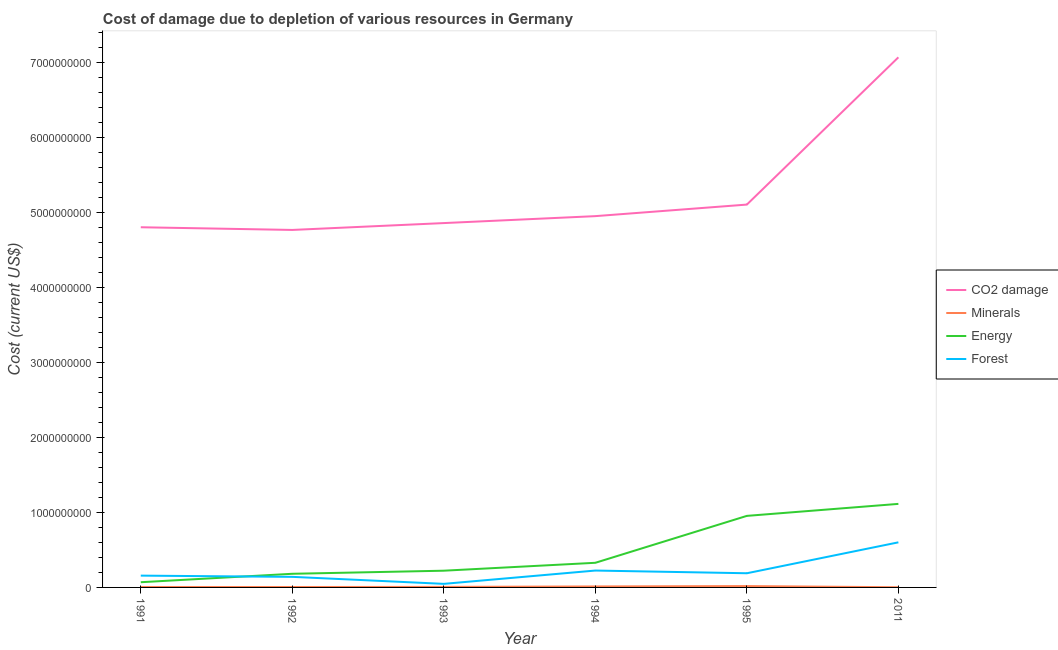Does the line corresponding to cost of damage due to depletion of coal intersect with the line corresponding to cost of damage due to depletion of energy?
Provide a succinct answer. No. What is the cost of damage due to depletion of minerals in 1992?
Your response must be concise. 5.79e+06. Across all years, what is the maximum cost of damage due to depletion of energy?
Offer a terse response. 1.11e+09. Across all years, what is the minimum cost of damage due to depletion of minerals?
Ensure brevity in your answer.  2.65e+06. In which year was the cost of damage due to depletion of minerals minimum?
Make the answer very short. 2011. What is the total cost of damage due to depletion of minerals in the graph?
Offer a very short reply. 5.21e+07. What is the difference between the cost of damage due to depletion of energy in 1995 and that in 2011?
Your response must be concise. -1.60e+08. What is the difference between the cost of damage due to depletion of minerals in 1991 and the cost of damage due to depletion of forests in 1995?
Your response must be concise. -1.83e+08. What is the average cost of damage due to depletion of coal per year?
Keep it short and to the point. 5.26e+09. In the year 1995, what is the difference between the cost of damage due to depletion of minerals and cost of damage due to depletion of energy?
Provide a succinct answer. -9.37e+08. In how many years, is the cost of damage due to depletion of coal greater than 4000000000 US$?
Provide a short and direct response. 6. What is the ratio of the cost of damage due to depletion of coal in 1991 to that in 2011?
Keep it short and to the point. 0.68. Is the difference between the cost of damage due to depletion of energy in 1992 and 1995 greater than the difference between the cost of damage due to depletion of minerals in 1992 and 1995?
Provide a short and direct response. No. What is the difference between the highest and the second highest cost of damage due to depletion of forests?
Keep it short and to the point. 3.76e+08. What is the difference between the highest and the lowest cost of damage due to depletion of coal?
Your answer should be very brief. 2.30e+09. In how many years, is the cost of damage due to depletion of minerals greater than the average cost of damage due to depletion of minerals taken over all years?
Offer a very short reply. 2. Does the cost of damage due to depletion of minerals monotonically increase over the years?
Give a very brief answer. No. Is the cost of damage due to depletion of minerals strictly greater than the cost of damage due to depletion of energy over the years?
Make the answer very short. No. What is the difference between two consecutive major ticks on the Y-axis?
Your response must be concise. 1.00e+09. What is the title of the graph?
Keep it short and to the point. Cost of damage due to depletion of various resources in Germany . What is the label or title of the Y-axis?
Provide a short and direct response. Cost (current US$). What is the Cost (current US$) of CO2 damage in 1991?
Offer a very short reply. 4.80e+09. What is the Cost (current US$) of Minerals in 1991?
Ensure brevity in your answer.  5.85e+06. What is the Cost (current US$) of Energy in 1991?
Offer a terse response. 6.95e+07. What is the Cost (current US$) of Forest in 1991?
Your answer should be compact. 1.57e+08. What is the Cost (current US$) in CO2 damage in 1992?
Ensure brevity in your answer.  4.77e+09. What is the Cost (current US$) in Minerals in 1992?
Make the answer very short. 5.79e+06. What is the Cost (current US$) of Energy in 1992?
Keep it short and to the point. 1.82e+08. What is the Cost (current US$) of Forest in 1992?
Your answer should be compact. 1.41e+08. What is the Cost (current US$) of CO2 damage in 1993?
Keep it short and to the point. 4.86e+09. What is the Cost (current US$) of Minerals in 1993?
Your response must be concise. 7.05e+06. What is the Cost (current US$) in Energy in 1993?
Give a very brief answer. 2.23e+08. What is the Cost (current US$) of Forest in 1993?
Offer a terse response. 4.76e+07. What is the Cost (current US$) in CO2 damage in 1994?
Offer a very short reply. 4.95e+09. What is the Cost (current US$) in Minerals in 1994?
Your answer should be very brief. 1.30e+07. What is the Cost (current US$) of Energy in 1994?
Your answer should be very brief. 3.29e+08. What is the Cost (current US$) in Forest in 1994?
Your response must be concise. 2.25e+08. What is the Cost (current US$) of CO2 damage in 1995?
Give a very brief answer. 5.11e+09. What is the Cost (current US$) in Minerals in 1995?
Offer a terse response. 1.77e+07. What is the Cost (current US$) in Energy in 1995?
Offer a very short reply. 9.54e+08. What is the Cost (current US$) of Forest in 1995?
Provide a short and direct response. 1.89e+08. What is the Cost (current US$) in CO2 damage in 2011?
Offer a very short reply. 7.07e+09. What is the Cost (current US$) in Minerals in 2011?
Offer a very short reply. 2.65e+06. What is the Cost (current US$) in Energy in 2011?
Your answer should be compact. 1.11e+09. What is the Cost (current US$) in Forest in 2011?
Provide a short and direct response. 6.01e+08. Across all years, what is the maximum Cost (current US$) in CO2 damage?
Provide a short and direct response. 7.07e+09. Across all years, what is the maximum Cost (current US$) in Minerals?
Provide a succinct answer. 1.77e+07. Across all years, what is the maximum Cost (current US$) in Energy?
Provide a succinct answer. 1.11e+09. Across all years, what is the maximum Cost (current US$) of Forest?
Offer a terse response. 6.01e+08. Across all years, what is the minimum Cost (current US$) of CO2 damage?
Your response must be concise. 4.77e+09. Across all years, what is the minimum Cost (current US$) in Minerals?
Ensure brevity in your answer.  2.65e+06. Across all years, what is the minimum Cost (current US$) in Energy?
Your answer should be very brief. 6.95e+07. Across all years, what is the minimum Cost (current US$) of Forest?
Give a very brief answer. 4.76e+07. What is the total Cost (current US$) in CO2 damage in the graph?
Keep it short and to the point. 3.16e+1. What is the total Cost (current US$) in Minerals in the graph?
Offer a very short reply. 5.21e+07. What is the total Cost (current US$) in Energy in the graph?
Ensure brevity in your answer.  2.87e+09. What is the total Cost (current US$) of Forest in the graph?
Give a very brief answer. 1.36e+09. What is the difference between the Cost (current US$) in CO2 damage in 1991 and that in 1992?
Your answer should be compact. 3.59e+07. What is the difference between the Cost (current US$) in Minerals in 1991 and that in 1992?
Offer a very short reply. 6.23e+04. What is the difference between the Cost (current US$) of Energy in 1991 and that in 1992?
Offer a terse response. -1.13e+08. What is the difference between the Cost (current US$) in Forest in 1991 and that in 1992?
Offer a terse response. 1.64e+07. What is the difference between the Cost (current US$) in CO2 damage in 1991 and that in 1993?
Your answer should be compact. -5.56e+07. What is the difference between the Cost (current US$) in Minerals in 1991 and that in 1993?
Your answer should be very brief. -1.19e+06. What is the difference between the Cost (current US$) of Energy in 1991 and that in 1993?
Your answer should be compact. -1.54e+08. What is the difference between the Cost (current US$) in Forest in 1991 and that in 1993?
Offer a terse response. 1.10e+08. What is the difference between the Cost (current US$) in CO2 damage in 1991 and that in 1994?
Keep it short and to the point. -1.48e+08. What is the difference between the Cost (current US$) of Minerals in 1991 and that in 1994?
Your answer should be compact. -7.17e+06. What is the difference between the Cost (current US$) of Energy in 1991 and that in 1994?
Ensure brevity in your answer.  -2.59e+08. What is the difference between the Cost (current US$) in Forest in 1991 and that in 1994?
Keep it short and to the point. -6.78e+07. What is the difference between the Cost (current US$) of CO2 damage in 1991 and that in 1995?
Give a very brief answer. -3.02e+08. What is the difference between the Cost (current US$) in Minerals in 1991 and that in 1995?
Provide a short and direct response. -1.19e+07. What is the difference between the Cost (current US$) of Energy in 1991 and that in 1995?
Offer a very short reply. -8.85e+08. What is the difference between the Cost (current US$) in Forest in 1991 and that in 1995?
Provide a succinct answer. -3.16e+07. What is the difference between the Cost (current US$) in CO2 damage in 1991 and that in 2011?
Ensure brevity in your answer.  -2.27e+09. What is the difference between the Cost (current US$) in Minerals in 1991 and that in 2011?
Give a very brief answer. 3.20e+06. What is the difference between the Cost (current US$) in Energy in 1991 and that in 2011?
Give a very brief answer. -1.04e+09. What is the difference between the Cost (current US$) in Forest in 1991 and that in 2011?
Make the answer very short. -4.44e+08. What is the difference between the Cost (current US$) of CO2 damage in 1992 and that in 1993?
Offer a terse response. -9.15e+07. What is the difference between the Cost (current US$) in Minerals in 1992 and that in 1993?
Offer a very short reply. -1.26e+06. What is the difference between the Cost (current US$) in Energy in 1992 and that in 1993?
Provide a short and direct response. -4.12e+07. What is the difference between the Cost (current US$) of Forest in 1992 and that in 1993?
Give a very brief answer. 9.35e+07. What is the difference between the Cost (current US$) in CO2 damage in 1992 and that in 1994?
Offer a very short reply. -1.84e+08. What is the difference between the Cost (current US$) in Minerals in 1992 and that in 1994?
Offer a terse response. -7.23e+06. What is the difference between the Cost (current US$) of Energy in 1992 and that in 1994?
Ensure brevity in your answer.  -1.47e+08. What is the difference between the Cost (current US$) in Forest in 1992 and that in 1994?
Your answer should be very brief. -8.41e+07. What is the difference between the Cost (current US$) of CO2 damage in 1992 and that in 1995?
Offer a terse response. -3.38e+08. What is the difference between the Cost (current US$) in Minerals in 1992 and that in 1995?
Offer a terse response. -1.19e+07. What is the difference between the Cost (current US$) of Energy in 1992 and that in 1995?
Your answer should be very brief. -7.72e+08. What is the difference between the Cost (current US$) of Forest in 1992 and that in 1995?
Provide a short and direct response. -4.80e+07. What is the difference between the Cost (current US$) in CO2 damage in 1992 and that in 2011?
Offer a terse response. -2.30e+09. What is the difference between the Cost (current US$) in Minerals in 1992 and that in 2011?
Provide a succinct answer. 3.14e+06. What is the difference between the Cost (current US$) in Energy in 1992 and that in 2011?
Ensure brevity in your answer.  -9.32e+08. What is the difference between the Cost (current US$) of Forest in 1992 and that in 2011?
Offer a very short reply. -4.60e+08. What is the difference between the Cost (current US$) in CO2 damage in 1993 and that in 1994?
Offer a very short reply. -9.26e+07. What is the difference between the Cost (current US$) of Minerals in 1993 and that in 1994?
Keep it short and to the point. -5.97e+06. What is the difference between the Cost (current US$) of Energy in 1993 and that in 1994?
Give a very brief answer. -1.05e+08. What is the difference between the Cost (current US$) in Forest in 1993 and that in 1994?
Make the answer very short. -1.78e+08. What is the difference between the Cost (current US$) of CO2 damage in 1993 and that in 1995?
Offer a terse response. -2.47e+08. What is the difference between the Cost (current US$) of Minerals in 1993 and that in 1995?
Keep it short and to the point. -1.07e+07. What is the difference between the Cost (current US$) in Energy in 1993 and that in 1995?
Your answer should be compact. -7.31e+08. What is the difference between the Cost (current US$) in Forest in 1993 and that in 1995?
Offer a terse response. -1.41e+08. What is the difference between the Cost (current US$) of CO2 damage in 1993 and that in 2011?
Your response must be concise. -2.21e+09. What is the difference between the Cost (current US$) of Minerals in 1993 and that in 2011?
Ensure brevity in your answer.  4.39e+06. What is the difference between the Cost (current US$) of Energy in 1993 and that in 2011?
Provide a short and direct response. -8.91e+08. What is the difference between the Cost (current US$) of Forest in 1993 and that in 2011?
Your answer should be very brief. -5.54e+08. What is the difference between the Cost (current US$) in CO2 damage in 1994 and that in 1995?
Your answer should be very brief. -1.54e+08. What is the difference between the Cost (current US$) of Minerals in 1994 and that in 1995?
Make the answer very short. -4.72e+06. What is the difference between the Cost (current US$) in Energy in 1994 and that in 1995?
Your answer should be very brief. -6.26e+08. What is the difference between the Cost (current US$) in Forest in 1994 and that in 1995?
Offer a very short reply. 3.62e+07. What is the difference between the Cost (current US$) of CO2 damage in 1994 and that in 2011?
Give a very brief answer. -2.12e+09. What is the difference between the Cost (current US$) in Minerals in 1994 and that in 2011?
Your answer should be compact. 1.04e+07. What is the difference between the Cost (current US$) in Energy in 1994 and that in 2011?
Make the answer very short. -7.86e+08. What is the difference between the Cost (current US$) in Forest in 1994 and that in 2011?
Offer a very short reply. -3.76e+08. What is the difference between the Cost (current US$) in CO2 damage in 1995 and that in 2011?
Ensure brevity in your answer.  -1.96e+09. What is the difference between the Cost (current US$) in Minerals in 1995 and that in 2011?
Your answer should be compact. 1.51e+07. What is the difference between the Cost (current US$) in Energy in 1995 and that in 2011?
Your answer should be compact. -1.60e+08. What is the difference between the Cost (current US$) in Forest in 1995 and that in 2011?
Make the answer very short. -4.12e+08. What is the difference between the Cost (current US$) of CO2 damage in 1991 and the Cost (current US$) of Minerals in 1992?
Offer a very short reply. 4.80e+09. What is the difference between the Cost (current US$) of CO2 damage in 1991 and the Cost (current US$) of Energy in 1992?
Your answer should be very brief. 4.62e+09. What is the difference between the Cost (current US$) of CO2 damage in 1991 and the Cost (current US$) of Forest in 1992?
Keep it short and to the point. 4.66e+09. What is the difference between the Cost (current US$) in Minerals in 1991 and the Cost (current US$) in Energy in 1992?
Keep it short and to the point. -1.76e+08. What is the difference between the Cost (current US$) in Minerals in 1991 and the Cost (current US$) in Forest in 1992?
Provide a short and direct response. -1.35e+08. What is the difference between the Cost (current US$) in Energy in 1991 and the Cost (current US$) in Forest in 1992?
Provide a succinct answer. -7.16e+07. What is the difference between the Cost (current US$) in CO2 damage in 1991 and the Cost (current US$) in Minerals in 1993?
Your answer should be compact. 4.80e+09. What is the difference between the Cost (current US$) of CO2 damage in 1991 and the Cost (current US$) of Energy in 1993?
Your answer should be very brief. 4.58e+09. What is the difference between the Cost (current US$) in CO2 damage in 1991 and the Cost (current US$) in Forest in 1993?
Provide a short and direct response. 4.76e+09. What is the difference between the Cost (current US$) of Minerals in 1991 and the Cost (current US$) of Energy in 1993?
Give a very brief answer. -2.17e+08. What is the difference between the Cost (current US$) in Minerals in 1991 and the Cost (current US$) in Forest in 1993?
Offer a very short reply. -4.17e+07. What is the difference between the Cost (current US$) of Energy in 1991 and the Cost (current US$) of Forest in 1993?
Give a very brief answer. 2.19e+07. What is the difference between the Cost (current US$) in CO2 damage in 1991 and the Cost (current US$) in Minerals in 1994?
Keep it short and to the point. 4.79e+09. What is the difference between the Cost (current US$) of CO2 damage in 1991 and the Cost (current US$) of Energy in 1994?
Provide a short and direct response. 4.48e+09. What is the difference between the Cost (current US$) of CO2 damage in 1991 and the Cost (current US$) of Forest in 1994?
Your response must be concise. 4.58e+09. What is the difference between the Cost (current US$) of Minerals in 1991 and the Cost (current US$) of Energy in 1994?
Provide a succinct answer. -3.23e+08. What is the difference between the Cost (current US$) in Minerals in 1991 and the Cost (current US$) in Forest in 1994?
Your answer should be compact. -2.19e+08. What is the difference between the Cost (current US$) of Energy in 1991 and the Cost (current US$) of Forest in 1994?
Give a very brief answer. -1.56e+08. What is the difference between the Cost (current US$) of CO2 damage in 1991 and the Cost (current US$) of Minerals in 1995?
Your answer should be compact. 4.79e+09. What is the difference between the Cost (current US$) in CO2 damage in 1991 and the Cost (current US$) in Energy in 1995?
Give a very brief answer. 3.85e+09. What is the difference between the Cost (current US$) of CO2 damage in 1991 and the Cost (current US$) of Forest in 1995?
Make the answer very short. 4.62e+09. What is the difference between the Cost (current US$) of Minerals in 1991 and the Cost (current US$) of Energy in 1995?
Offer a terse response. -9.48e+08. What is the difference between the Cost (current US$) of Minerals in 1991 and the Cost (current US$) of Forest in 1995?
Offer a terse response. -1.83e+08. What is the difference between the Cost (current US$) of Energy in 1991 and the Cost (current US$) of Forest in 1995?
Give a very brief answer. -1.20e+08. What is the difference between the Cost (current US$) in CO2 damage in 1991 and the Cost (current US$) in Minerals in 2011?
Provide a short and direct response. 4.80e+09. What is the difference between the Cost (current US$) of CO2 damage in 1991 and the Cost (current US$) of Energy in 2011?
Your answer should be very brief. 3.69e+09. What is the difference between the Cost (current US$) in CO2 damage in 1991 and the Cost (current US$) in Forest in 2011?
Give a very brief answer. 4.20e+09. What is the difference between the Cost (current US$) in Minerals in 1991 and the Cost (current US$) in Energy in 2011?
Offer a terse response. -1.11e+09. What is the difference between the Cost (current US$) of Minerals in 1991 and the Cost (current US$) of Forest in 2011?
Ensure brevity in your answer.  -5.96e+08. What is the difference between the Cost (current US$) in Energy in 1991 and the Cost (current US$) in Forest in 2011?
Provide a short and direct response. -5.32e+08. What is the difference between the Cost (current US$) in CO2 damage in 1992 and the Cost (current US$) in Minerals in 1993?
Your answer should be very brief. 4.76e+09. What is the difference between the Cost (current US$) in CO2 damage in 1992 and the Cost (current US$) in Energy in 1993?
Offer a terse response. 4.55e+09. What is the difference between the Cost (current US$) of CO2 damage in 1992 and the Cost (current US$) of Forest in 1993?
Your response must be concise. 4.72e+09. What is the difference between the Cost (current US$) in Minerals in 1992 and the Cost (current US$) in Energy in 1993?
Ensure brevity in your answer.  -2.17e+08. What is the difference between the Cost (current US$) of Minerals in 1992 and the Cost (current US$) of Forest in 1993?
Ensure brevity in your answer.  -4.18e+07. What is the difference between the Cost (current US$) of Energy in 1992 and the Cost (current US$) of Forest in 1993?
Offer a terse response. 1.34e+08. What is the difference between the Cost (current US$) of CO2 damage in 1992 and the Cost (current US$) of Minerals in 1994?
Offer a terse response. 4.76e+09. What is the difference between the Cost (current US$) in CO2 damage in 1992 and the Cost (current US$) in Energy in 1994?
Your response must be concise. 4.44e+09. What is the difference between the Cost (current US$) of CO2 damage in 1992 and the Cost (current US$) of Forest in 1994?
Give a very brief answer. 4.54e+09. What is the difference between the Cost (current US$) of Minerals in 1992 and the Cost (current US$) of Energy in 1994?
Offer a terse response. -3.23e+08. What is the difference between the Cost (current US$) of Minerals in 1992 and the Cost (current US$) of Forest in 1994?
Provide a succinct answer. -2.19e+08. What is the difference between the Cost (current US$) in Energy in 1992 and the Cost (current US$) in Forest in 1994?
Your response must be concise. -4.32e+07. What is the difference between the Cost (current US$) of CO2 damage in 1992 and the Cost (current US$) of Minerals in 1995?
Make the answer very short. 4.75e+09. What is the difference between the Cost (current US$) of CO2 damage in 1992 and the Cost (current US$) of Energy in 1995?
Offer a terse response. 3.81e+09. What is the difference between the Cost (current US$) of CO2 damage in 1992 and the Cost (current US$) of Forest in 1995?
Provide a short and direct response. 4.58e+09. What is the difference between the Cost (current US$) in Minerals in 1992 and the Cost (current US$) in Energy in 1995?
Ensure brevity in your answer.  -9.49e+08. What is the difference between the Cost (current US$) in Minerals in 1992 and the Cost (current US$) in Forest in 1995?
Your answer should be compact. -1.83e+08. What is the difference between the Cost (current US$) of Energy in 1992 and the Cost (current US$) of Forest in 1995?
Provide a short and direct response. -7.03e+06. What is the difference between the Cost (current US$) in CO2 damage in 1992 and the Cost (current US$) in Minerals in 2011?
Your answer should be compact. 4.77e+09. What is the difference between the Cost (current US$) of CO2 damage in 1992 and the Cost (current US$) of Energy in 2011?
Ensure brevity in your answer.  3.65e+09. What is the difference between the Cost (current US$) in CO2 damage in 1992 and the Cost (current US$) in Forest in 2011?
Offer a terse response. 4.17e+09. What is the difference between the Cost (current US$) in Minerals in 1992 and the Cost (current US$) in Energy in 2011?
Make the answer very short. -1.11e+09. What is the difference between the Cost (current US$) of Minerals in 1992 and the Cost (current US$) of Forest in 2011?
Give a very brief answer. -5.96e+08. What is the difference between the Cost (current US$) in Energy in 1992 and the Cost (current US$) in Forest in 2011?
Your answer should be very brief. -4.19e+08. What is the difference between the Cost (current US$) in CO2 damage in 1993 and the Cost (current US$) in Minerals in 1994?
Offer a very short reply. 4.85e+09. What is the difference between the Cost (current US$) of CO2 damage in 1993 and the Cost (current US$) of Energy in 1994?
Offer a terse response. 4.53e+09. What is the difference between the Cost (current US$) of CO2 damage in 1993 and the Cost (current US$) of Forest in 1994?
Make the answer very short. 4.63e+09. What is the difference between the Cost (current US$) of Minerals in 1993 and the Cost (current US$) of Energy in 1994?
Make the answer very short. -3.22e+08. What is the difference between the Cost (current US$) of Minerals in 1993 and the Cost (current US$) of Forest in 1994?
Your answer should be very brief. -2.18e+08. What is the difference between the Cost (current US$) in Energy in 1993 and the Cost (current US$) in Forest in 1994?
Offer a very short reply. -2.02e+06. What is the difference between the Cost (current US$) of CO2 damage in 1993 and the Cost (current US$) of Minerals in 1995?
Your response must be concise. 4.84e+09. What is the difference between the Cost (current US$) of CO2 damage in 1993 and the Cost (current US$) of Energy in 1995?
Provide a succinct answer. 3.91e+09. What is the difference between the Cost (current US$) of CO2 damage in 1993 and the Cost (current US$) of Forest in 1995?
Give a very brief answer. 4.67e+09. What is the difference between the Cost (current US$) in Minerals in 1993 and the Cost (current US$) in Energy in 1995?
Give a very brief answer. -9.47e+08. What is the difference between the Cost (current US$) of Minerals in 1993 and the Cost (current US$) of Forest in 1995?
Your answer should be compact. -1.82e+08. What is the difference between the Cost (current US$) of Energy in 1993 and the Cost (current US$) of Forest in 1995?
Your response must be concise. 3.41e+07. What is the difference between the Cost (current US$) in CO2 damage in 1993 and the Cost (current US$) in Minerals in 2011?
Provide a short and direct response. 4.86e+09. What is the difference between the Cost (current US$) of CO2 damage in 1993 and the Cost (current US$) of Energy in 2011?
Keep it short and to the point. 3.75e+09. What is the difference between the Cost (current US$) in CO2 damage in 1993 and the Cost (current US$) in Forest in 2011?
Provide a short and direct response. 4.26e+09. What is the difference between the Cost (current US$) of Minerals in 1993 and the Cost (current US$) of Energy in 2011?
Provide a succinct answer. -1.11e+09. What is the difference between the Cost (current US$) in Minerals in 1993 and the Cost (current US$) in Forest in 2011?
Ensure brevity in your answer.  -5.94e+08. What is the difference between the Cost (current US$) in Energy in 1993 and the Cost (current US$) in Forest in 2011?
Provide a short and direct response. -3.78e+08. What is the difference between the Cost (current US$) of CO2 damage in 1994 and the Cost (current US$) of Minerals in 1995?
Give a very brief answer. 4.93e+09. What is the difference between the Cost (current US$) in CO2 damage in 1994 and the Cost (current US$) in Energy in 1995?
Offer a very short reply. 4.00e+09. What is the difference between the Cost (current US$) of CO2 damage in 1994 and the Cost (current US$) of Forest in 1995?
Offer a terse response. 4.76e+09. What is the difference between the Cost (current US$) in Minerals in 1994 and the Cost (current US$) in Energy in 1995?
Ensure brevity in your answer.  -9.41e+08. What is the difference between the Cost (current US$) in Minerals in 1994 and the Cost (current US$) in Forest in 1995?
Your response must be concise. -1.76e+08. What is the difference between the Cost (current US$) in Energy in 1994 and the Cost (current US$) in Forest in 1995?
Make the answer very short. 1.40e+08. What is the difference between the Cost (current US$) of CO2 damage in 1994 and the Cost (current US$) of Minerals in 2011?
Provide a succinct answer. 4.95e+09. What is the difference between the Cost (current US$) in CO2 damage in 1994 and the Cost (current US$) in Energy in 2011?
Provide a short and direct response. 3.84e+09. What is the difference between the Cost (current US$) of CO2 damage in 1994 and the Cost (current US$) of Forest in 2011?
Keep it short and to the point. 4.35e+09. What is the difference between the Cost (current US$) of Minerals in 1994 and the Cost (current US$) of Energy in 2011?
Provide a short and direct response. -1.10e+09. What is the difference between the Cost (current US$) in Minerals in 1994 and the Cost (current US$) in Forest in 2011?
Provide a short and direct response. -5.88e+08. What is the difference between the Cost (current US$) in Energy in 1994 and the Cost (current US$) in Forest in 2011?
Keep it short and to the point. -2.73e+08. What is the difference between the Cost (current US$) in CO2 damage in 1995 and the Cost (current US$) in Minerals in 2011?
Offer a very short reply. 5.10e+09. What is the difference between the Cost (current US$) of CO2 damage in 1995 and the Cost (current US$) of Energy in 2011?
Provide a short and direct response. 3.99e+09. What is the difference between the Cost (current US$) in CO2 damage in 1995 and the Cost (current US$) in Forest in 2011?
Offer a very short reply. 4.50e+09. What is the difference between the Cost (current US$) in Minerals in 1995 and the Cost (current US$) in Energy in 2011?
Ensure brevity in your answer.  -1.10e+09. What is the difference between the Cost (current US$) of Minerals in 1995 and the Cost (current US$) of Forest in 2011?
Make the answer very short. -5.84e+08. What is the difference between the Cost (current US$) in Energy in 1995 and the Cost (current US$) in Forest in 2011?
Keep it short and to the point. 3.53e+08. What is the average Cost (current US$) of CO2 damage per year?
Provide a short and direct response. 5.26e+09. What is the average Cost (current US$) of Minerals per year?
Provide a succinct answer. 8.68e+06. What is the average Cost (current US$) in Energy per year?
Your answer should be compact. 4.79e+08. What is the average Cost (current US$) in Forest per year?
Your response must be concise. 2.27e+08. In the year 1991, what is the difference between the Cost (current US$) of CO2 damage and Cost (current US$) of Minerals?
Make the answer very short. 4.80e+09. In the year 1991, what is the difference between the Cost (current US$) of CO2 damage and Cost (current US$) of Energy?
Provide a succinct answer. 4.73e+09. In the year 1991, what is the difference between the Cost (current US$) in CO2 damage and Cost (current US$) in Forest?
Make the answer very short. 4.65e+09. In the year 1991, what is the difference between the Cost (current US$) of Minerals and Cost (current US$) of Energy?
Offer a terse response. -6.36e+07. In the year 1991, what is the difference between the Cost (current US$) in Minerals and Cost (current US$) in Forest?
Ensure brevity in your answer.  -1.52e+08. In the year 1991, what is the difference between the Cost (current US$) of Energy and Cost (current US$) of Forest?
Give a very brief answer. -8.79e+07. In the year 1992, what is the difference between the Cost (current US$) of CO2 damage and Cost (current US$) of Minerals?
Make the answer very short. 4.76e+09. In the year 1992, what is the difference between the Cost (current US$) in CO2 damage and Cost (current US$) in Energy?
Your answer should be very brief. 4.59e+09. In the year 1992, what is the difference between the Cost (current US$) in CO2 damage and Cost (current US$) in Forest?
Provide a short and direct response. 4.63e+09. In the year 1992, what is the difference between the Cost (current US$) of Minerals and Cost (current US$) of Energy?
Make the answer very short. -1.76e+08. In the year 1992, what is the difference between the Cost (current US$) in Minerals and Cost (current US$) in Forest?
Give a very brief answer. -1.35e+08. In the year 1992, what is the difference between the Cost (current US$) of Energy and Cost (current US$) of Forest?
Keep it short and to the point. 4.09e+07. In the year 1993, what is the difference between the Cost (current US$) of CO2 damage and Cost (current US$) of Minerals?
Give a very brief answer. 4.85e+09. In the year 1993, what is the difference between the Cost (current US$) of CO2 damage and Cost (current US$) of Energy?
Provide a succinct answer. 4.64e+09. In the year 1993, what is the difference between the Cost (current US$) in CO2 damage and Cost (current US$) in Forest?
Your answer should be very brief. 4.81e+09. In the year 1993, what is the difference between the Cost (current US$) of Minerals and Cost (current US$) of Energy?
Your answer should be very brief. -2.16e+08. In the year 1993, what is the difference between the Cost (current US$) in Minerals and Cost (current US$) in Forest?
Keep it short and to the point. -4.05e+07. In the year 1993, what is the difference between the Cost (current US$) of Energy and Cost (current US$) of Forest?
Offer a terse response. 1.76e+08. In the year 1994, what is the difference between the Cost (current US$) in CO2 damage and Cost (current US$) in Minerals?
Ensure brevity in your answer.  4.94e+09. In the year 1994, what is the difference between the Cost (current US$) in CO2 damage and Cost (current US$) in Energy?
Offer a very short reply. 4.62e+09. In the year 1994, what is the difference between the Cost (current US$) of CO2 damage and Cost (current US$) of Forest?
Offer a terse response. 4.73e+09. In the year 1994, what is the difference between the Cost (current US$) in Minerals and Cost (current US$) in Energy?
Your answer should be compact. -3.16e+08. In the year 1994, what is the difference between the Cost (current US$) in Minerals and Cost (current US$) in Forest?
Offer a very short reply. -2.12e+08. In the year 1994, what is the difference between the Cost (current US$) in Energy and Cost (current US$) in Forest?
Keep it short and to the point. 1.03e+08. In the year 1995, what is the difference between the Cost (current US$) of CO2 damage and Cost (current US$) of Minerals?
Ensure brevity in your answer.  5.09e+09. In the year 1995, what is the difference between the Cost (current US$) of CO2 damage and Cost (current US$) of Energy?
Provide a short and direct response. 4.15e+09. In the year 1995, what is the difference between the Cost (current US$) of CO2 damage and Cost (current US$) of Forest?
Give a very brief answer. 4.92e+09. In the year 1995, what is the difference between the Cost (current US$) in Minerals and Cost (current US$) in Energy?
Your response must be concise. -9.37e+08. In the year 1995, what is the difference between the Cost (current US$) of Minerals and Cost (current US$) of Forest?
Provide a short and direct response. -1.71e+08. In the year 1995, what is the difference between the Cost (current US$) of Energy and Cost (current US$) of Forest?
Provide a short and direct response. 7.65e+08. In the year 2011, what is the difference between the Cost (current US$) of CO2 damage and Cost (current US$) of Minerals?
Your answer should be very brief. 7.07e+09. In the year 2011, what is the difference between the Cost (current US$) in CO2 damage and Cost (current US$) in Energy?
Your answer should be very brief. 5.96e+09. In the year 2011, what is the difference between the Cost (current US$) of CO2 damage and Cost (current US$) of Forest?
Your response must be concise. 6.47e+09. In the year 2011, what is the difference between the Cost (current US$) of Minerals and Cost (current US$) of Energy?
Make the answer very short. -1.11e+09. In the year 2011, what is the difference between the Cost (current US$) in Minerals and Cost (current US$) in Forest?
Your response must be concise. -5.99e+08. In the year 2011, what is the difference between the Cost (current US$) of Energy and Cost (current US$) of Forest?
Keep it short and to the point. 5.13e+08. What is the ratio of the Cost (current US$) in CO2 damage in 1991 to that in 1992?
Your answer should be very brief. 1.01. What is the ratio of the Cost (current US$) of Minerals in 1991 to that in 1992?
Give a very brief answer. 1.01. What is the ratio of the Cost (current US$) of Energy in 1991 to that in 1992?
Your answer should be compact. 0.38. What is the ratio of the Cost (current US$) in Forest in 1991 to that in 1992?
Your response must be concise. 1.12. What is the ratio of the Cost (current US$) in Minerals in 1991 to that in 1993?
Your answer should be compact. 0.83. What is the ratio of the Cost (current US$) of Energy in 1991 to that in 1993?
Your answer should be compact. 0.31. What is the ratio of the Cost (current US$) of Forest in 1991 to that in 1993?
Give a very brief answer. 3.31. What is the ratio of the Cost (current US$) in CO2 damage in 1991 to that in 1994?
Keep it short and to the point. 0.97. What is the ratio of the Cost (current US$) of Minerals in 1991 to that in 1994?
Keep it short and to the point. 0.45. What is the ratio of the Cost (current US$) of Energy in 1991 to that in 1994?
Offer a terse response. 0.21. What is the ratio of the Cost (current US$) in Forest in 1991 to that in 1994?
Keep it short and to the point. 0.7. What is the ratio of the Cost (current US$) in CO2 damage in 1991 to that in 1995?
Offer a very short reply. 0.94. What is the ratio of the Cost (current US$) of Minerals in 1991 to that in 1995?
Your answer should be compact. 0.33. What is the ratio of the Cost (current US$) in Energy in 1991 to that in 1995?
Give a very brief answer. 0.07. What is the ratio of the Cost (current US$) of Forest in 1991 to that in 1995?
Ensure brevity in your answer.  0.83. What is the ratio of the Cost (current US$) in CO2 damage in 1991 to that in 2011?
Offer a terse response. 0.68. What is the ratio of the Cost (current US$) of Minerals in 1991 to that in 2011?
Your answer should be compact. 2.21. What is the ratio of the Cost (current US$) of Energy in 1991 to that in 2011?
Make the answer very short. 0.06. What is the ratio of the Cost (current US$) of Forest in 1991 to that in 2011?
Provide a short and direct response. 0.26. What is the ratio of the Cost (current US$) of CO2 damage in 1992 to that in 1993?
Provide a short and direct response. 0.98. What is the ratio of the Cost (current US$) of Minerals in 1992 to that in 1993?
Make the answer very short. 0.82. What is the ratio of the Cost (current US$) in Energy in 1992 to that in 1993?
Offer a very short reply. 0.82. What is the ratio of the Cost (current US$) in Forest in 1992 to that in 1993?
Offer a very short reply. 2.97. What is the ratio of the Cost (current US$) of CO2 damage in 1992 to that in 1994?
Offer a very short reply. 0.96. What is the ratio of the Cost (current US$) in Minerals in 1992 to that in 1994?
Offer a terse response. 0.44. What is the ratio of the Cost (current US$) of Energy in 1992 to that in 1994?
Your answer should be very brief. 0.55. What is the ratio of the Cost (current US$) of Forest in 1992 to that in 1994?
Your answer should be very brief. 0.63. What is the ratio of the Cost (current US$) in CO2 damage in 1992 to that in 1995?
Keep it short and to the point. 0.93. What is the ratio of the Cost (current US$) in Minerals in 1992 to that in 1995?
Give a very brief answer. 0.33. What is the ratio of the Cost (current US$) in Energy in 1992 to that in 1995?
Provide a succinct answer. 0.19. What is the ratio of the Cost (current US$) in Forest in 1992 to that in 1995?
Offer a very short reply. 0.75. What is the ratio of the Cost (current US$) in CO2 damage in 1992 to that in 2011?
Ensure brevity in your answer.  0.67. What is the ratio of the Cost (current US$) of Minerals in 1992 to that in 2011?
Keep it short and to the point. 2.18. What is the ratio of the Cost (current US$) of Energy in 1992 to that in 2011?
Provide a short and direct response. 0.16. What is the ratio of the Cost (current US$) of Forest in 1992 to that in 2011?
Ensure brevity in your answer.  0.23. What is the ratio of the Cost (current US$) of CO2 damage in 1993 to that in 1994?
Provide a succinct answer. 0.98. What is the ratio of the Cost (current US$) of Minerals in 1993 to that in 1994?
Ensure brevity in your answer.  0.54. What is the ratio of the Cost (current US$) in Energy in 1993 to that in 1994?
Make the answer very short. 0.68. What is the ratio of the Cost (current US$) in Forest in 1993 to that in 1994?
Offer a very short reply. 0.21. What is the ratio of the Cost (current US$) in CO2 damage in 1993 to that in 1995?
Make the answer very short. 0.95. What is the ratio of the Cost (current US$) of Minerals in 1993 to that in 1995?
Provide a short and direct response. 0.4. What is the ratio of the Cost (current US$) in Energy in 1993 to that in 1995?
Offer a very short reply. 0.23. What is the ratio of the Cost (current US$) in Forest in 1993 to that in 1995?
Provide a succinct answer. 0.25. What is the ratio of the Cost (current US$) of CO2 damage in 1993 to that in 2011?
Keep it short and to the point. 0.69. What is the ratio of the Cost (current US$) of Minerals in 1993 to that in 2011?
Your answer should be compact. 2.66. What is the ratio of the Cost (current US$) of Energy in 1993 to that in 2011?
Give a very brief answer. 0.2. What is the ratio of the Cost (current US$) of Forest in 1993 to that in 2011?
Your answer should be compact. 0.08. What is the ratio of the Cost (current US$) in CO2 damage in 1994 to that in 1995?
Provide a succinct answer. 0.97. What is the ratio of the Cost (current US$) in Minerals in 1994 to that in 1995?
Give a very brief answer. 0.73. What is the ratio of the Cost (current US$) of Energy in 1994 to that in 1995?
Offer a very short reply. 0.34. What is the ratio of the Cost (current US$) in Forest in 1994 to that in 1995?
Provide a succinct answer. 1.19. What is the ratio of the Cost (current US$) of CO2 damage in 1994 to that in 2011?
Make the answer very short. 0.7. What is the ratio of the Cost (current US$) of Minerals in 1994 to that in 2011?
Your answer should be very brief. 4.91. What is the ratio of the Cost (current US$) in Energy in 1994 to that in 2011?
Your response must be concise. 0.29. What is the ratio of the Cost (current US$) of Forest in 1994 to that in 2011?
Make the answer very short. 0.37. What is the ratio of the Cost (current US$) in CO2 damage in 1995 to that in 2011?
Provide a short and direct response. 0.72. What is the ratio of the Cost (current US$) of Minerals in 1995 to that in 2011?
Give a very brief answer. 6.68. What is the ratio of the Cost (current US$) of Energy in 1995 to that in 2011?
Offer a terse response. 0.86. What is the ratio of the Cost (current US$) of Forest in 1995 to that in 2011?
Offer a terse response. 0.31. What is the difference between the highest and the second highest Cost (current US$) in CO2 damage?
Your answer should be very brief. 1.96e+09. What is the difference between the highest and the second highest Cost (current US$) in Minerals?
Keep it short and to the point. 4.72e+06. What is the difference between the highest and the second highest Cost (current US$) of Energy?
Make the answer very short. 1.60e+08. What is the difference between the highest and the second highest Cost (current US$) in Forest?
Give a very brief answer. 3.76e+08. What is the difference between the highest and the lowest Cost (current US$) in CO2 damage?
Make the answer very short. 2.30e+09. What is the difference between the highest and the lowest Cost (current US$) of Minerals?
Your answer should be compact. 1.51e+07. What is the difference between the highest and the lowest Cost (current US$) of Energy?
Provide a succinct answer. 1.04e+09. What is the difference between the highest and the lowest Cost (current US$) of Forest?
Your answer should be compact. 5.54e+08. 